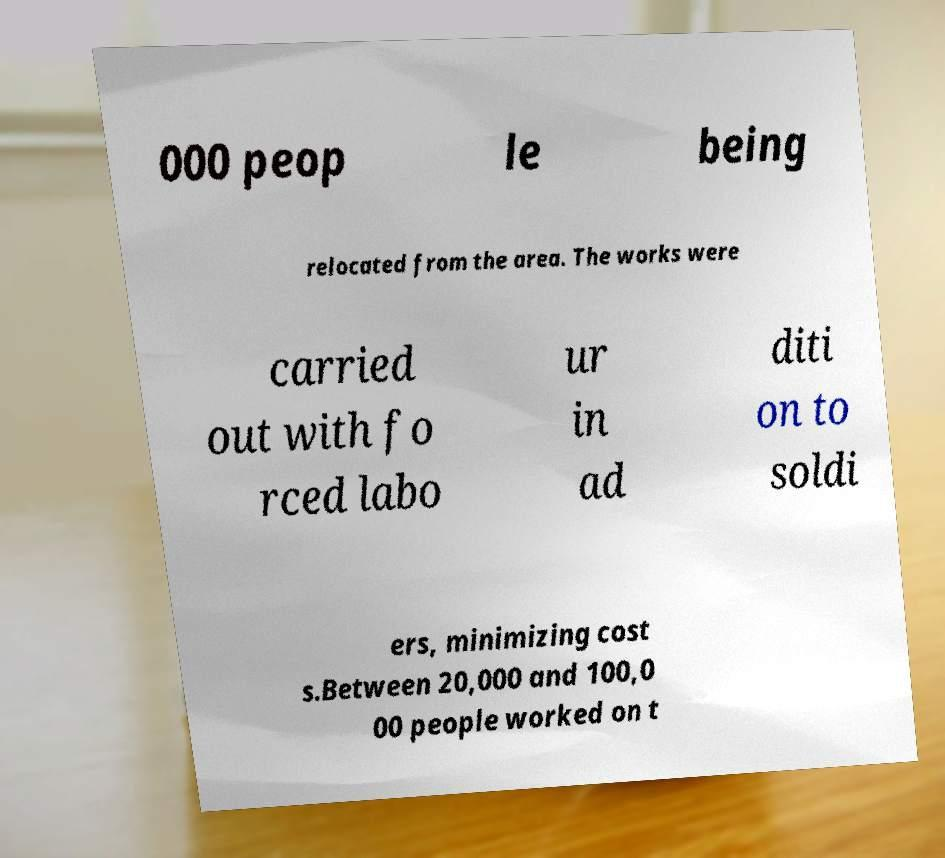Please read and relay the text visible in this image. What does it say? 000 peop le being relocated from the area. The works were carried out with fo rced labo ur in ad diti on to soldi ers, minimizing cost s.Between 20,000 and 100,0 00 people worked on t 